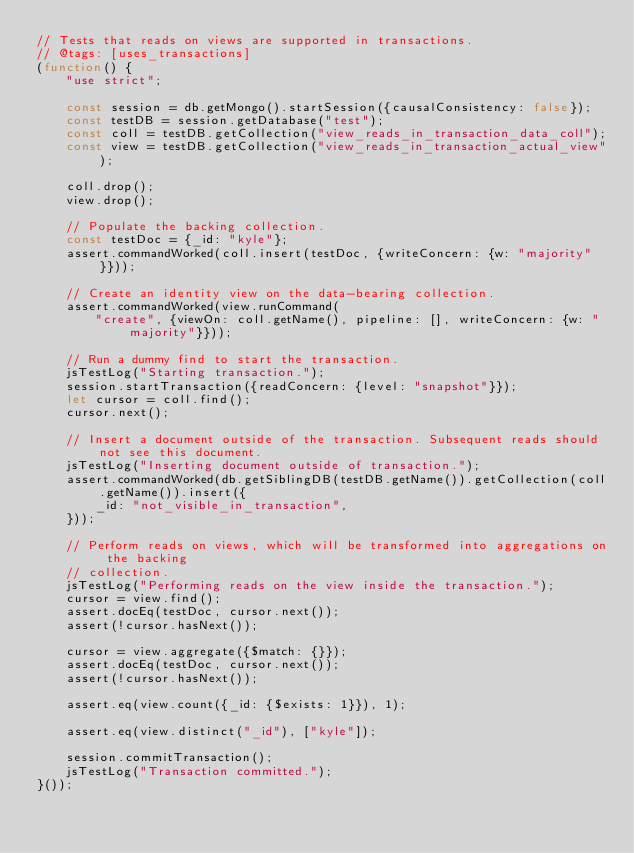Convert code to text. <code><loc_0><loc_0><loc_500><loc_500><_JavaScript_>// Tests that reads on views are supported in transactions.
// @tags: [uses_transactions]
(function() {
    "use strict";

    const session = db.getMongo().startSession({causalConsistency: false});
    const testDB = session.getDatabase("test");
    const coll = testDB.getCollection("view_reads_in_transaction_data_coll");
    const view = testDB.getCollection("view_reads_in_transaction_actual_view");

    coll.drop();
    view.drop();

    // Populate the backing collection.
    const testDoc = {_id: "kyle"};
    assert.commandWorked(coll.insert(testDoc, {writeConcern: {w: "majority"}}));

    // Create an identity view on the data-bearing collection.
    assert.commandWorked(view.runCommand(
        "create", {viewOn: coll.getName(), pipeline: [], writeConcern: {w: "majority"}}));

    // Run a dummy find to start the transaction.
    jsTestLog("Starting transaction.");
    session.startTransaction({readConcern: {level: "snapshot"}});
    let cursor = coll.find();
    cursor.next();

    // Insert a document outside of the transaction. Subsequent reads should not see this document.
    jsTestLog("Inserting document outside of transaction.");
    assert.commandWorked(db.getSiblingDB(testDB.getName()).getCollection(coll.getName()).insert({
        _id: "not_visible_in_transaction",
    }));

    // Perform reads on views, which will be transformed into aggregations on the backing
    // collection.
    jsTestLog("Performing reads on the view inside the transaction.");
    cursor = view.find();
    assert.docEq(testDoc, cursor.next());
    assert(!cursor.hasNext());

    cursor = view.aggregate({$match: {}});
    assert.docEq(testDoc, cursor.next());
    assert(!cursor.hasNext());

    assert.eq(view.count({_id: {$exists: 1}}), 1);

    assert.eq(view.distinct("_id"), ["kyle"]);

    session.commitTransaction();
    jsTestLog("Transaction committed.");
}());
</code> 